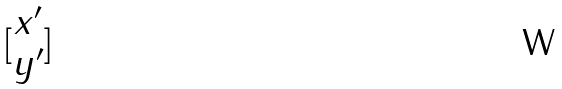Convert formula to latex. <formula><loc_0><loc_0><loc_500><loc_500>[ \begin{matrix} x ^ { \prime } \\ y ^ { \prime } \end{matrix} ]</formula> 